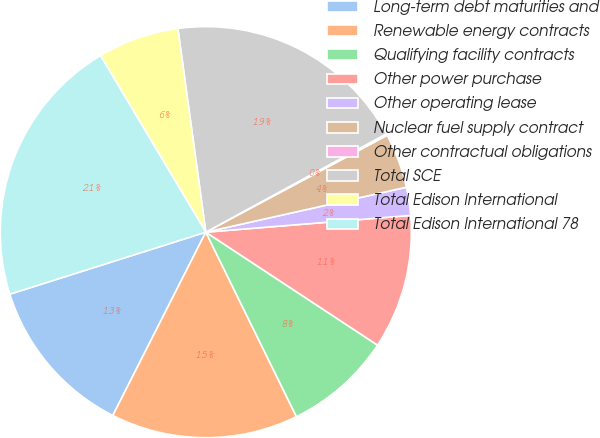Convert chart to OTSL. <chart><loc_0><loc_0><loc_500><loc_500><pie_chart><fcel>Long-term debt maturities and<fcel>Renewable energy contracts<fcel>Qualifying facility contracts<fcel>Other power purchase<fcel>Other operating lease<fcel>Nuclear fuel supply contract<fcel>Other contractual obligations<fcel>Total SCE<fcel>Total Edison International<fcel>Total Edison International 78<nl><fcel>12.65%<fcel>14.74%<fcel>8.47%<fcel>10.56%<fcel>2.21%<fcel>4.3%<fcel>0.13%<fcel>19.23%<fcel>6.39%<fcel>21.32%<nl></chart> 